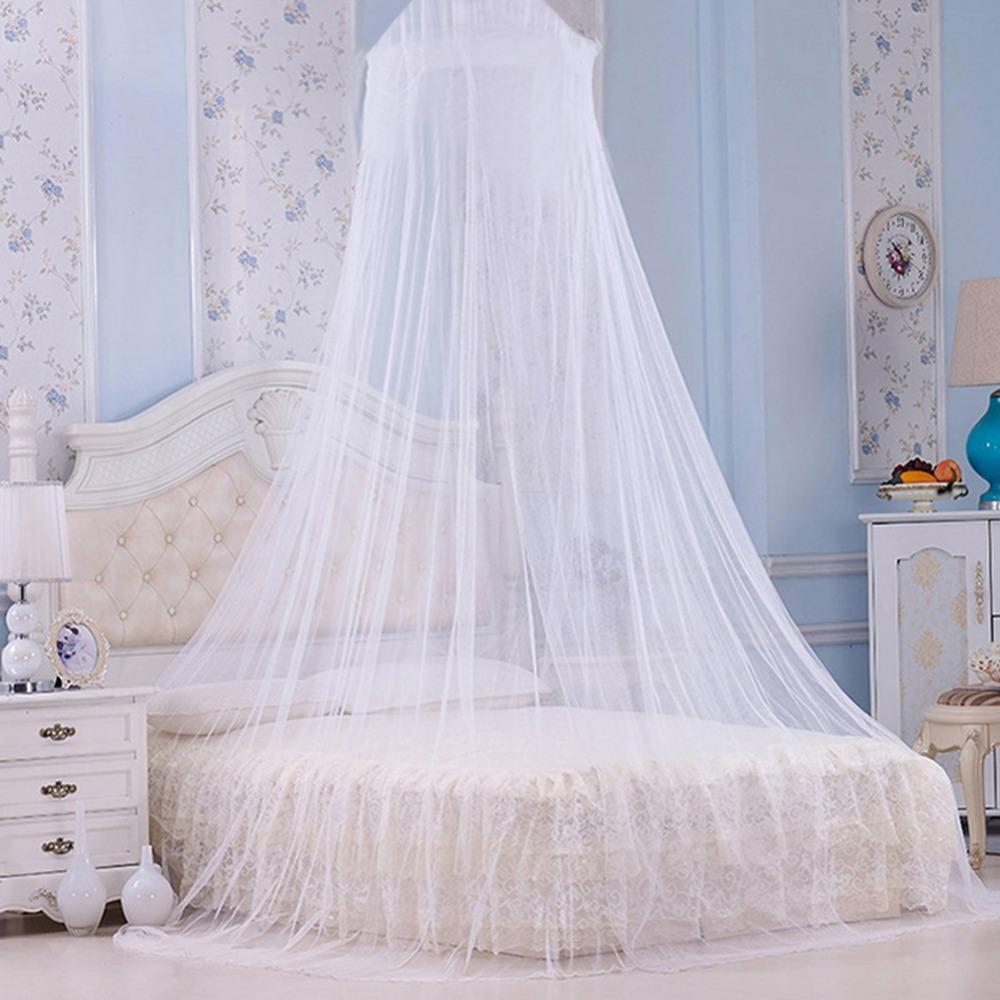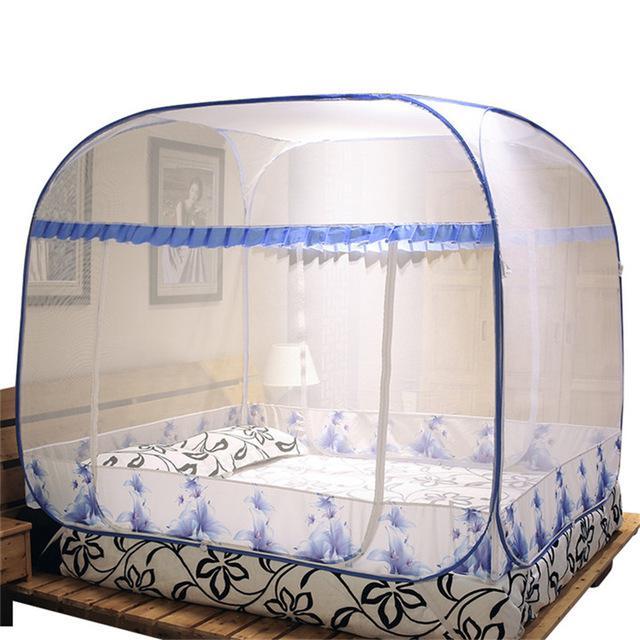The first image is the image on the left, the second image is the image on the right. Evaluate the accuracy of this statement regarding the images: "One bed net has a fabric bottom trim.". Is it true? Answer yes or no. Yes. The first image is the image on the left, the second image is the image on the right. Examine the images to the left and right. Is the description "One image shows a head-on view of a bed surrounded by a square sheer white canopy that covers the foot of the bed and suspends from its top corners." accurate? Answer yes or no. No. 